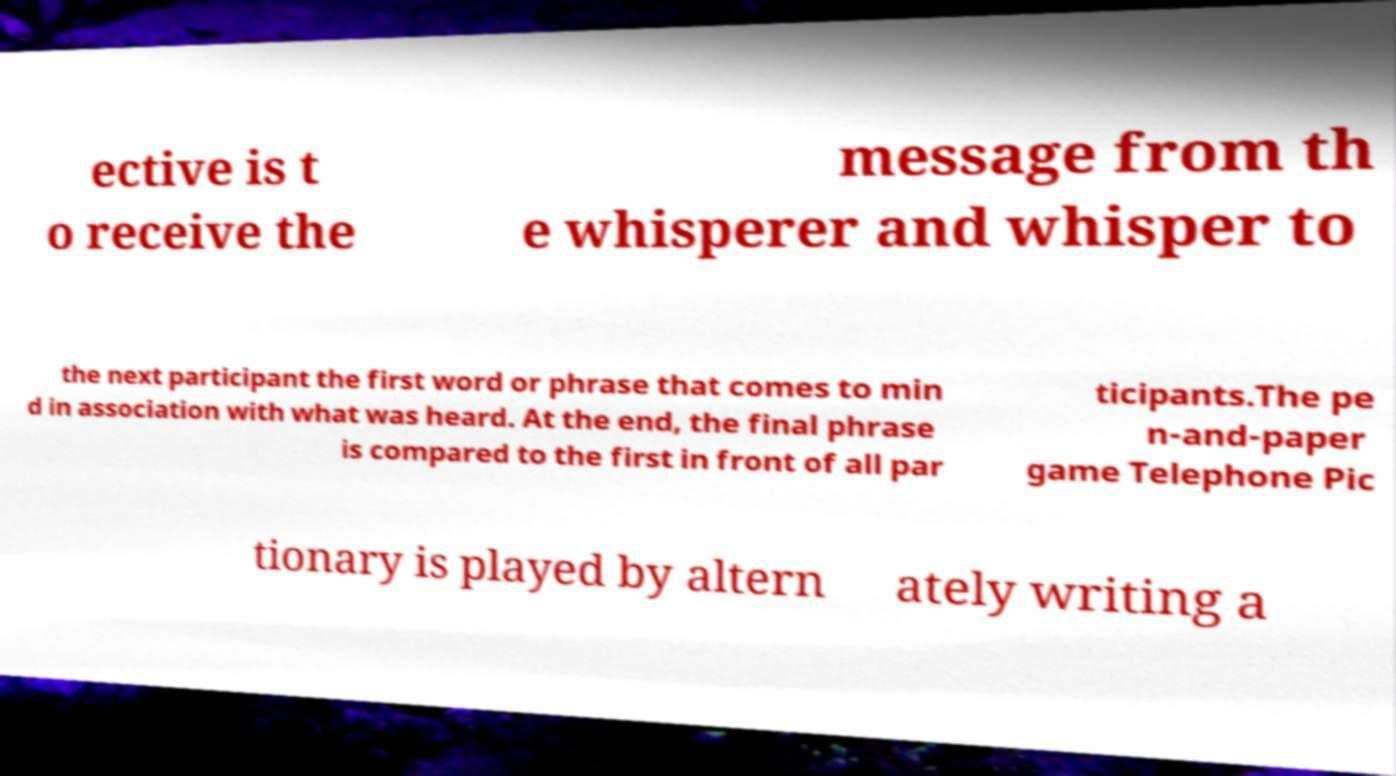Can you accurately transcribe the text from the provided image for me? ective is t o receive the message from th e whisperer and whisper to the next participant the first word or phrase that comes to min d in association with what was heard. At the end, the final phrase is compared to the first in front of all par ticipants.The pe n-and-paper game Telephone Pic tionary is played by altern ately writing a 